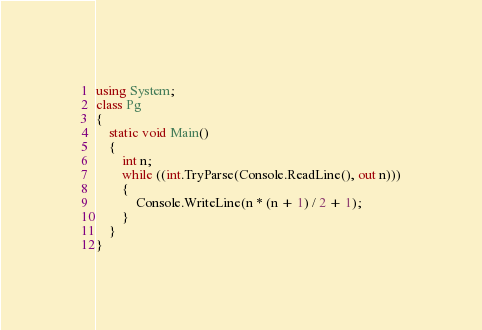<code> <loc_0><loc_0><loc_500><loc_500><_C#_>using System;
class Pg
{
    static void Main()
    {
        int n;
        while ((int.TryParse(Console.ReadLine(), out n)))
        {
            Console.WriteLine(n * (n + 1) / 2 + 1);
        }
    }
}
</code> 